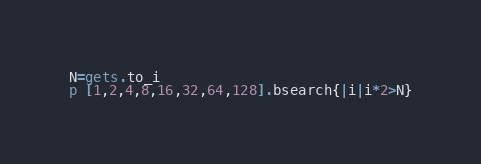Convert code to text. <code><loc_0><loc_0><loc_500><loc_500><_Ruby_>N=gets.to_i
p [1,2,4,8,16,32,64,128].bsearch{|i|i*2>N}</code> 